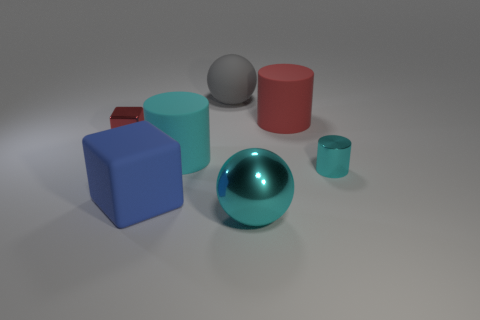What is the size of the other metallic thing that is the same color as the big metallic thing?
Make the answer very short. Small. There is a big rubber cylinder that is in front of the large red rubber cylinder; is it the same color as the tiny metal cylinder?
Your response must be concise. Yes. There is a tiny cylinder that is the same color as the large metallic thing; what is it made of?
Give a very brief answer. Metal. Is there a blue object made of the same material as the large red object?
Offer a very short reply. Yes. The tiny object that is right of the cyan metal thing that is in front of the small cyan object is made of what material?
Give a very brief answer. Metal. What is the material of the cyan object that is behind the large matte block and on the right side of the cyan matte cylinder?
Ensure brevity in your answer.  Metal. Are there an equal number of big red things on the right side of the red rubber thing and tiny yellow cubes?
Provide a succinct answer. Yes. What number of large metal things have the same shape as the large gray matte object?
Give a very brief answer. 1. There is a thing that is on the right side of the red thing that is on the right side of the shiny object that is to the left of the gray matte ball; what is its size?
Offer a terse response. Small. Are the ball in front of the small cube and the small red object made of the same material?
Give a very brief answer. Yes. 